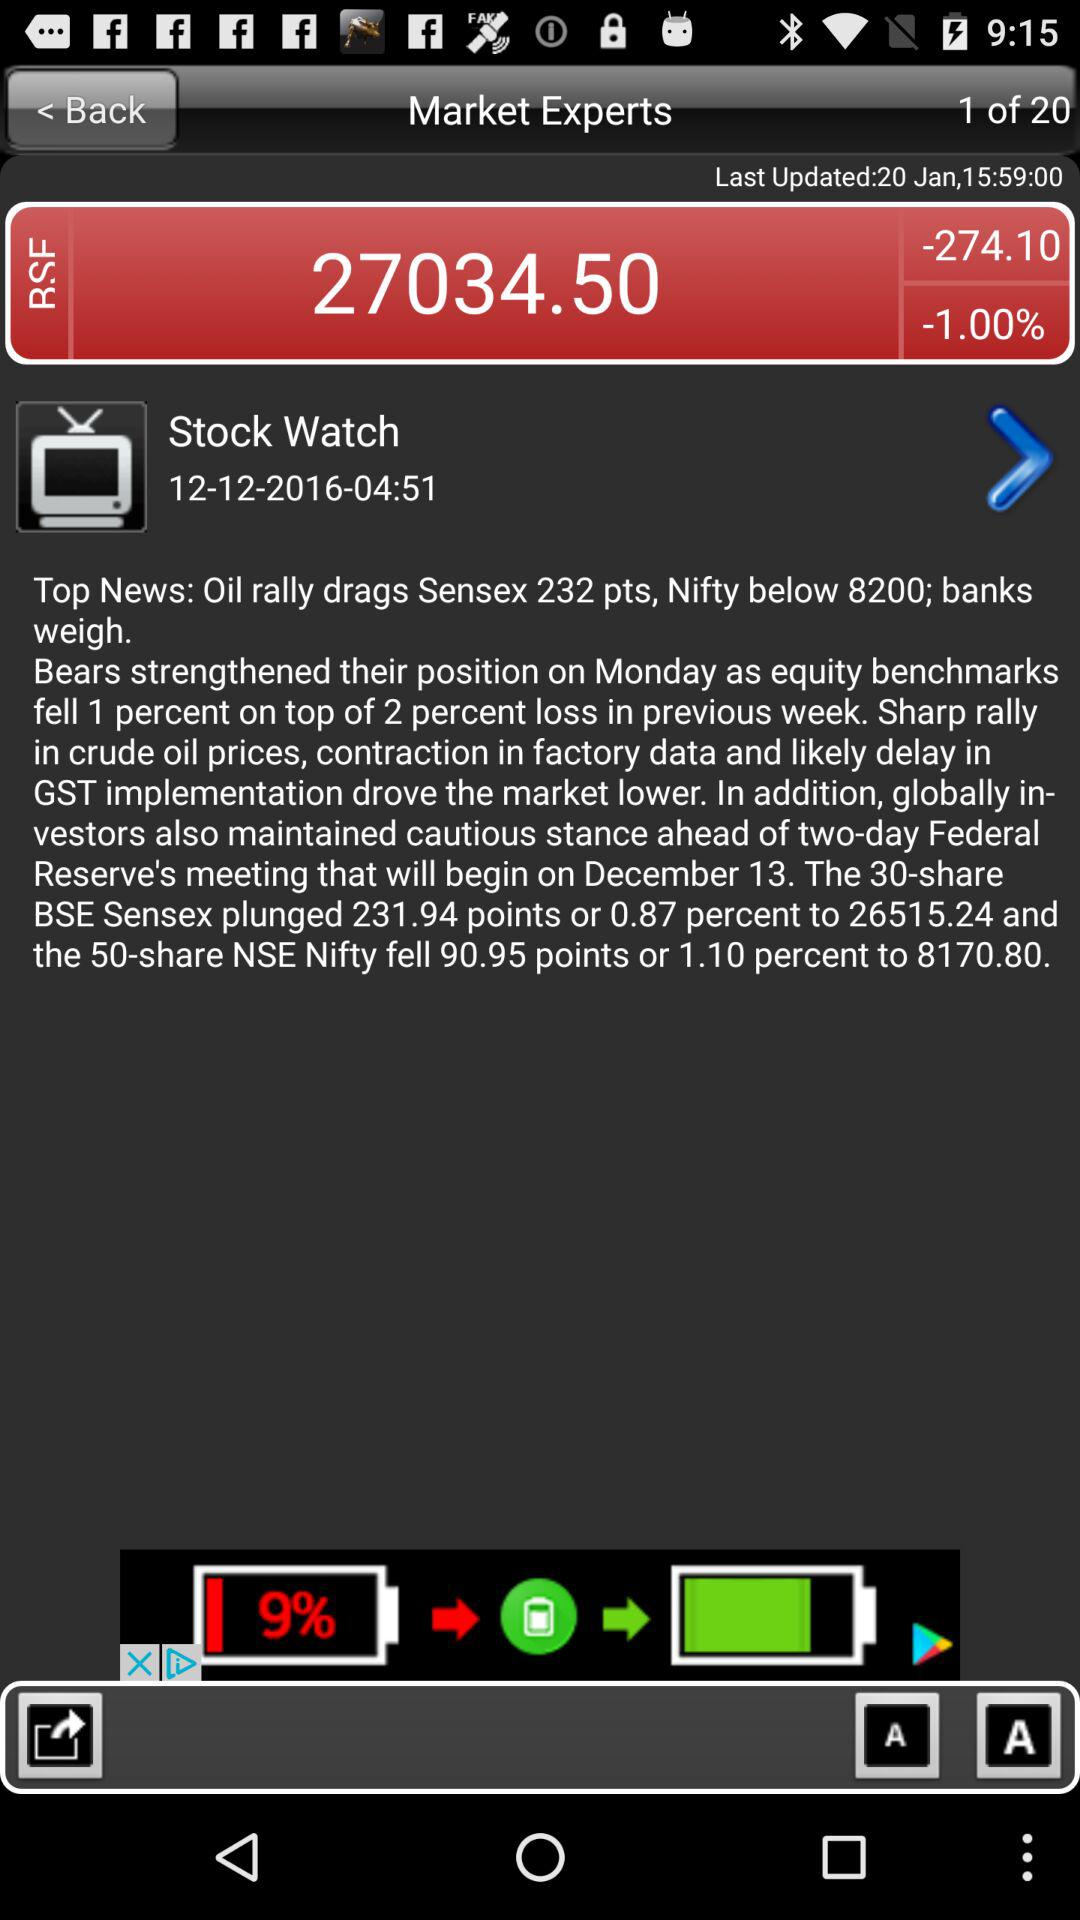What is the BSE value? The value of BSE is 27034.5. 